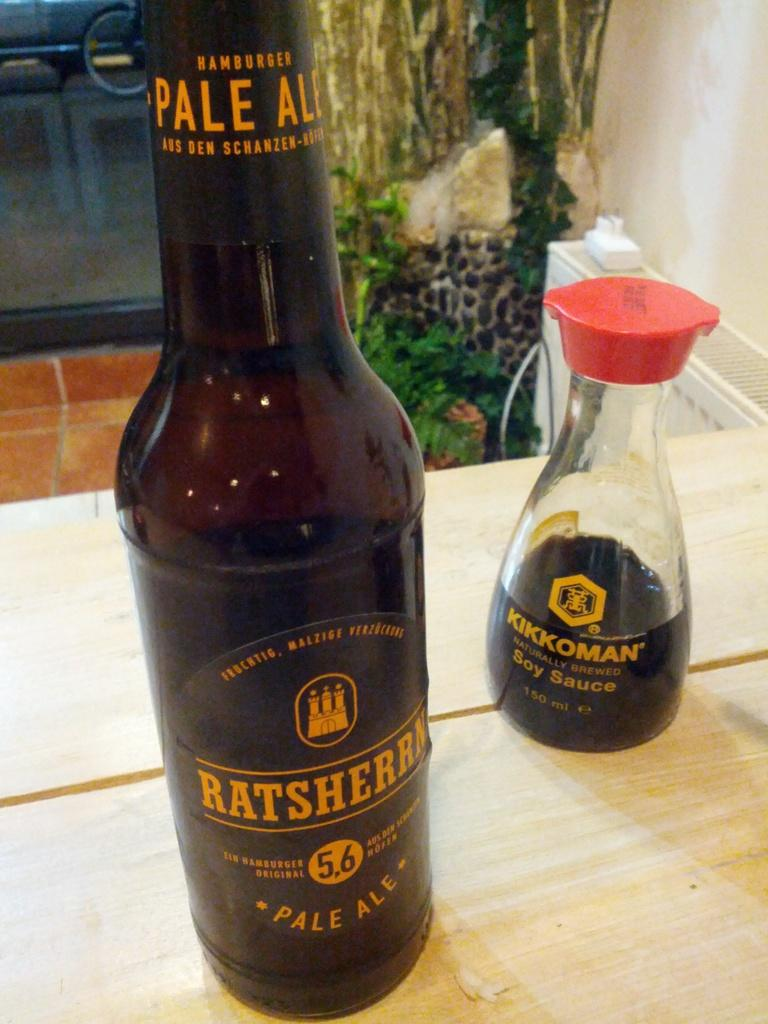Provide a one-sentence caption for the provided image. Dark Ratsherrn Pale Ale bottle next to a Kikkoman Soy Sauce. 